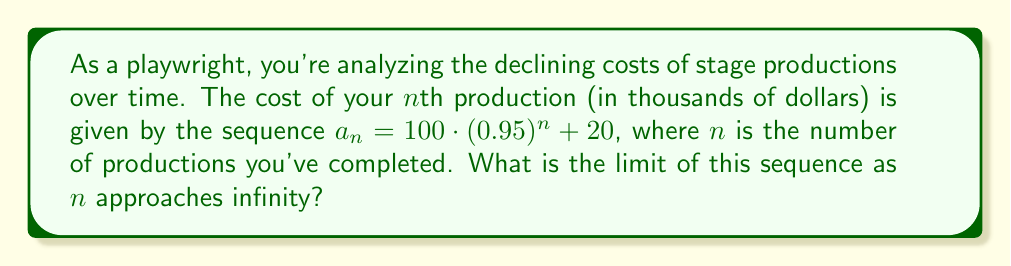What is the answer to this math problem? Let's approach this step-by-step:

1) The given sequence is $a_n = 100 \cdot (0.95)^n + 20$

2) To find the limit as n approaches infinity, we need to evaluate:
   $$\lim_{n \to \infty} (100 \cdot (0.95)^n + 20)$$

3) We can split this into two parts:
   $$\lim_{n \to \infty} 100 \cdot (0.95)^n + \lim_{n \to \infty} 20$$

4) The second part is easy: $\lim_{n \to \infty} 20 = 20$

5) For the first part, we need to consider the limit of $(0.95)^n$ as n approaches infinity:
   - Since 0.95 is less than 1, $(0.95)^n$ will approach 0 as n grows larger
   - Therefore, $\lim_{n \to \infty} (0.95)^n = 0$

6) This means:
   $$\lim_{n \to \infty} 100 \cdot (0.95)^n = 100 \cdot 0 = 0$$

7) Combining the results from steps 4 and 6:
   $$\lim_{n \to \infty} (100 \cdot (0.95)^n + 20) = 0 + 20 = 20$$

Thus, the limit of the sequence as n approaches infinity is 20.
Answer: $20$ 